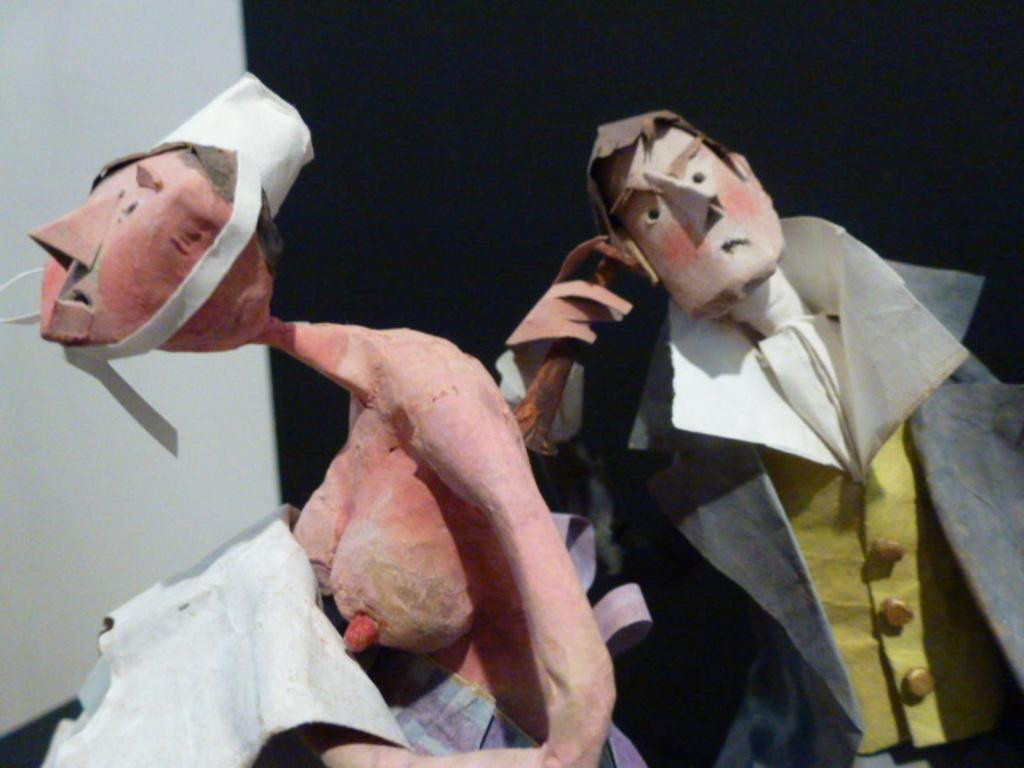How many toys are present in the image? There are two toys in the image. What are the toys shaped like? The toys are in the shape of persons. What colors are used in the background of the image? The background of the image is white and black colored. What type of rake is being used by the toys in the image? There is no rake present in the image. 